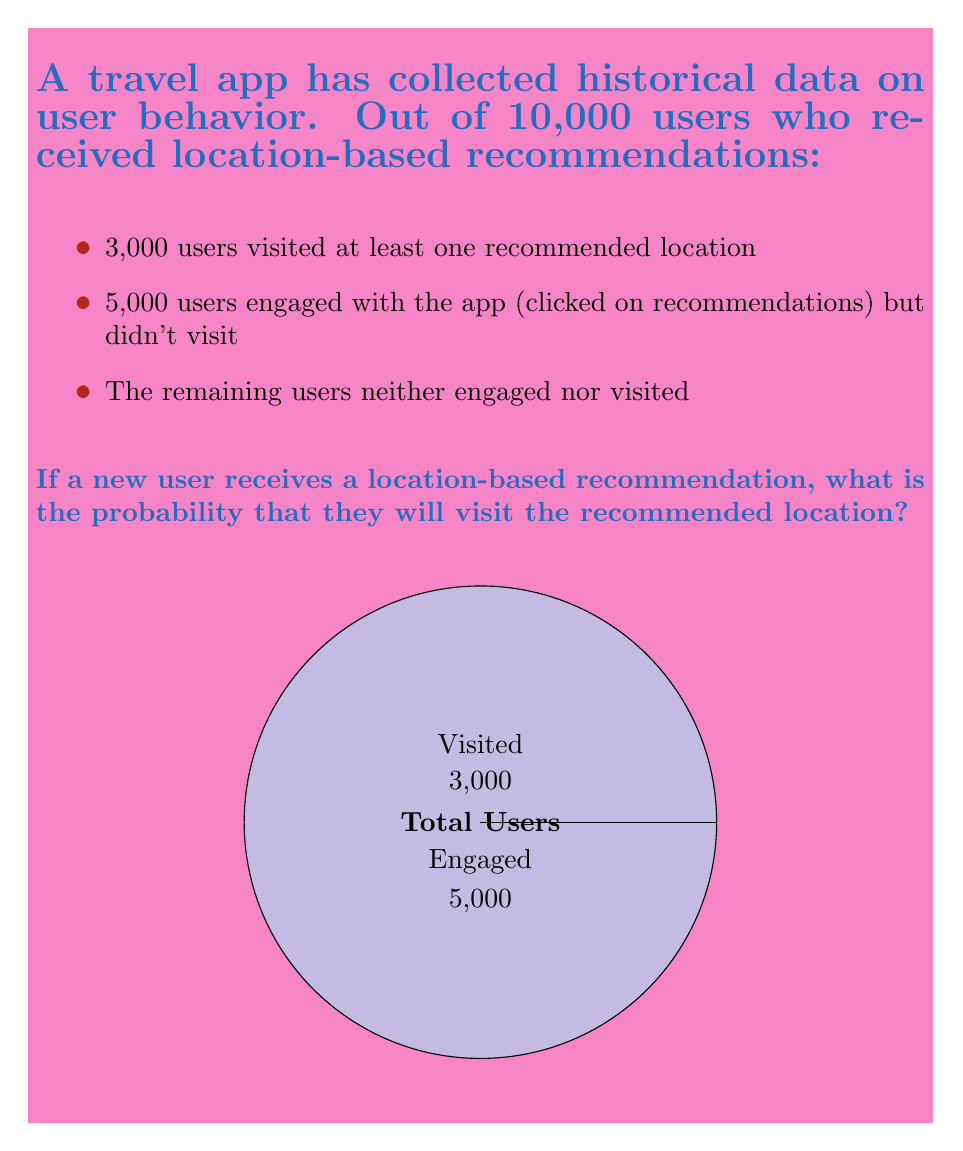Teach me how to tackle this problem. To solve this problem, we'll use the concept of probability based on historical data:

1) First, let's identify the total number of users and those who visited:
   - Total users: 10,000
   - Users who visited: 3,000

2) The probability is calculated by dividing the number of favorable outcomes by the total number of possible outcomes:

   $$P(\text{visit}) = \frac{\text{Number of users who visited}}{\text{Total number of users}}$$

3) Substituting the values:

   $$P(\text{visit}) = \frac{3,000}{10,000}$$

4) Simplify the fraction:

   $$P(\text{visit}) = \frac{3}{10} = 0.3$$

5) Convert to percentage:

   $$P(\text{visit}) = 0.3 \times 100\% = 30\%$$

Therefore, based on the historical data, there is a 30% probability that a new user will visit a recommended location.
Answer: $30\%$ 